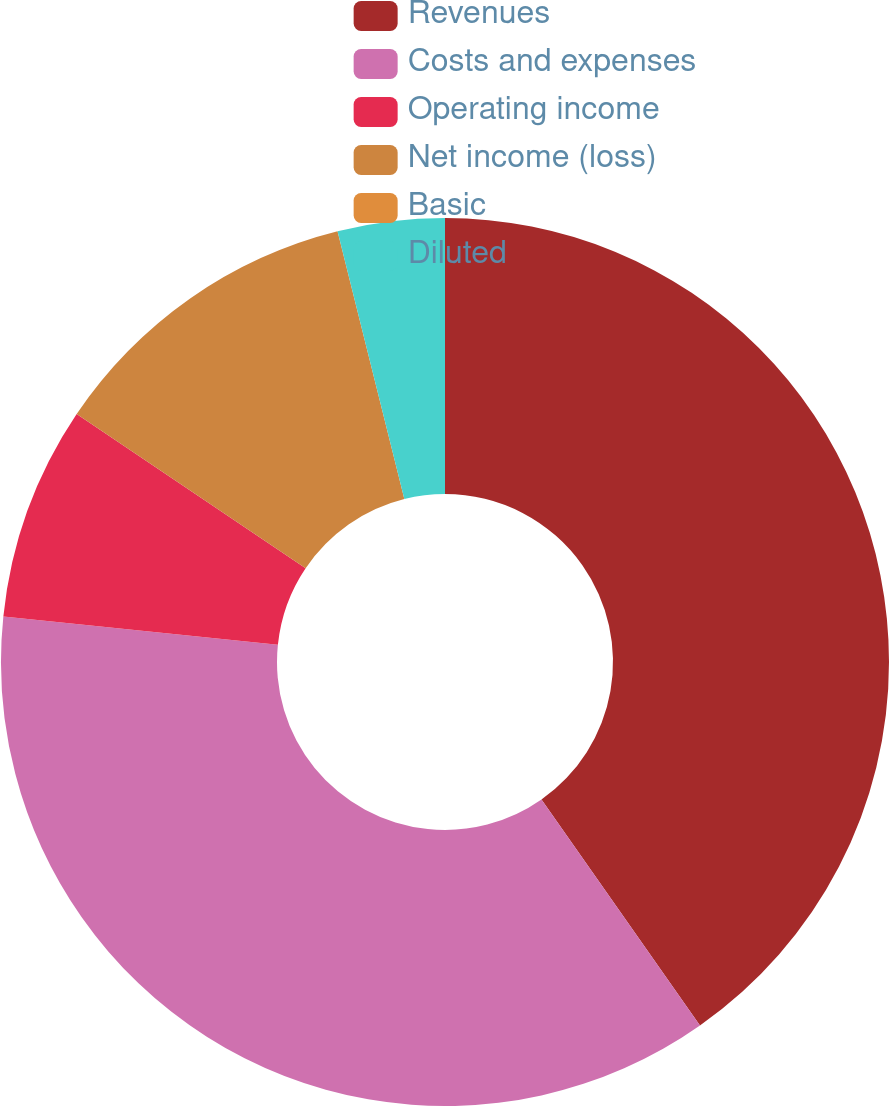Convert chart. <chart><loc_0><loc_0><loc_500><loc_500><pie_chart><fcel>Revenues<fcel>Costs and expenses<fcel>Operating income<fcel>Net income (loss)<fcel>Basic<fcel>Diluted<nl><fcel>40.26%<fcel>36.37%<fcel>7.79%<fcel>11.68%<fcel>0.0%<fcel>3.89%<nl></chart> 